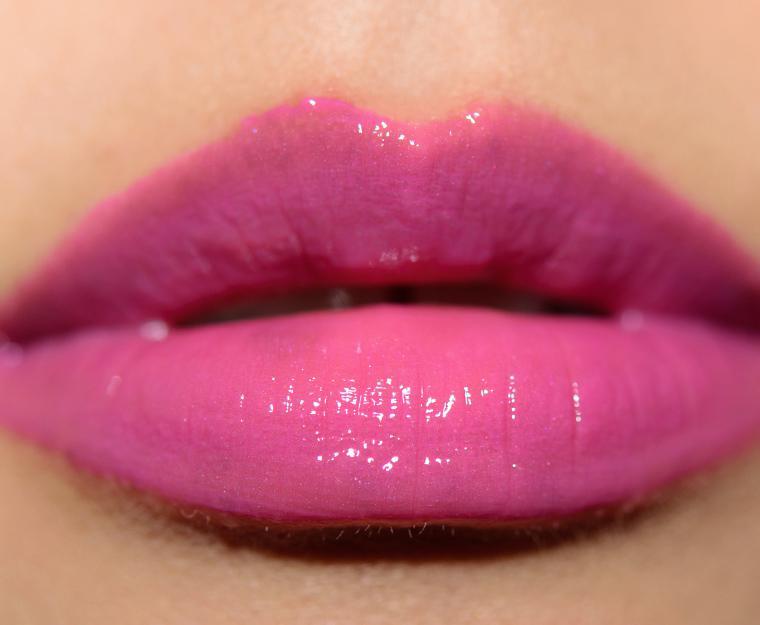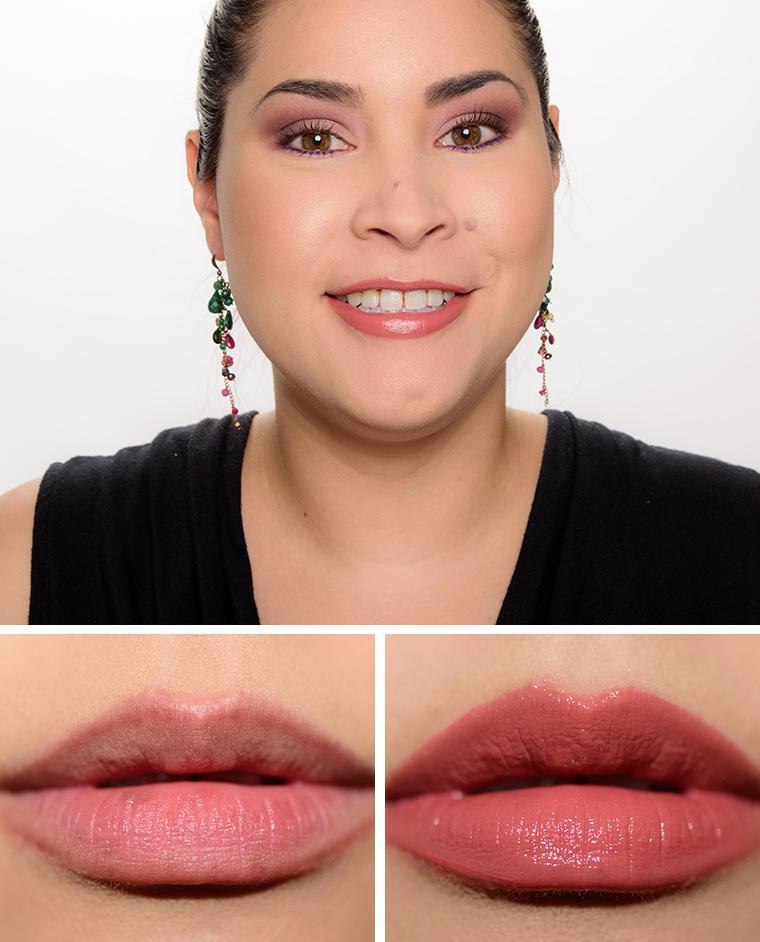The first image is the image on the left, the second image is the image on the right. For the images displayed, is the sentence "One photo is a closeup of tinted lips." factually correct? Answer yes or no. Yes. 